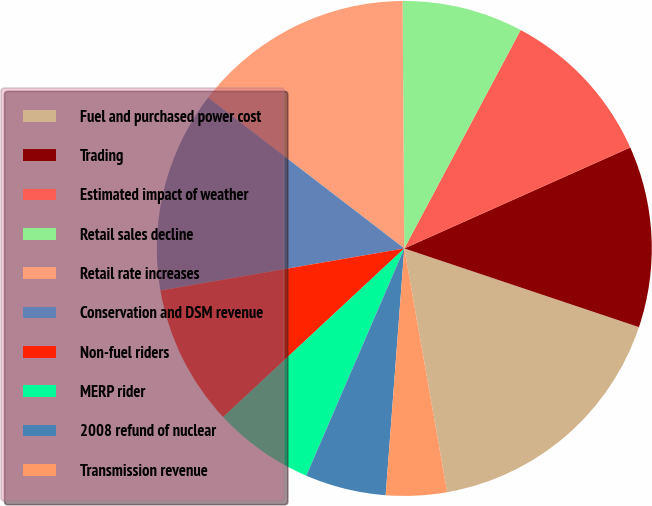Convert chart. <chart><loc_0><loc_0><loc_500><loc_500><pie_chart><fcel>Fuel and purchased power cost<fcel>Trading<fcel>Estimated impact of weather<fcel>Retail sales decline<fcel>Retail rate increases<fcel>Conservation and DSM revenue<fcel>Non-fuel riders<fcel>MERP rider<fcel>2008 refund of nuclear<fcel>Transmission revenue<nl><fcel>17.08%<fcel>11.84%<fcel>10.52%<fcel>7.9%<fcel>14.46%<fcel>13.15%<fcel>9.21%<fcel>6.59%<fcel>5.28%<fcel>3.97%<nl></chart> 